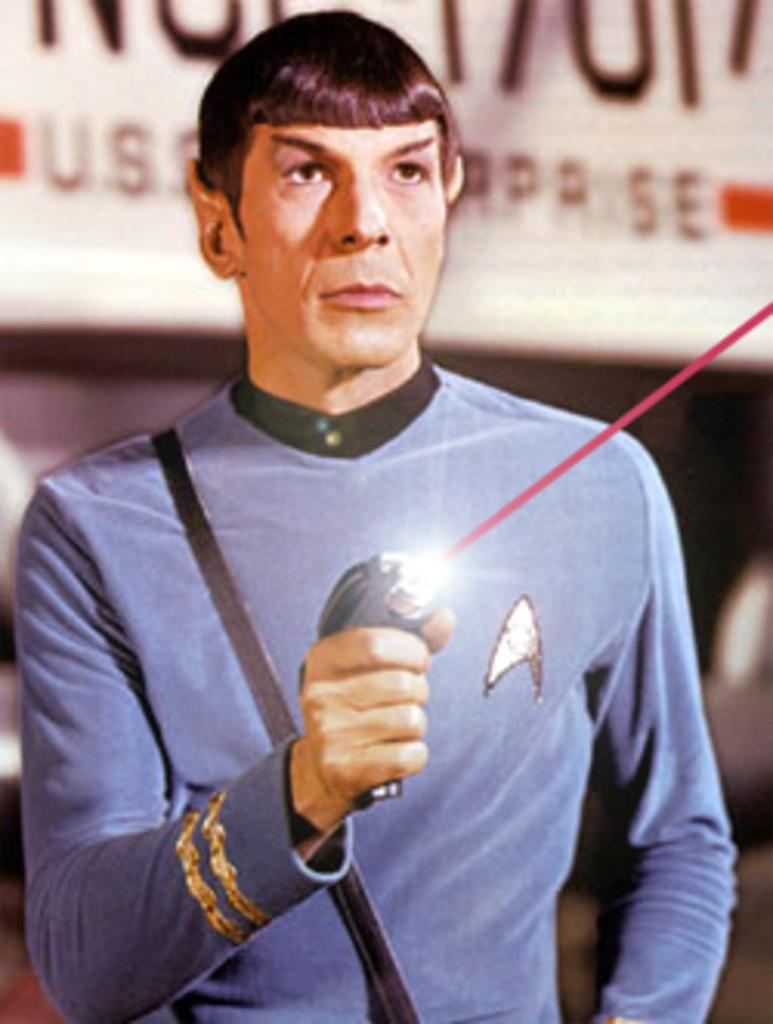Who is the main subject in the image? There is a person in the image. What is the person holding in the image? The person is holding a laser gun. Where is the person located in the image? The person is in the center of the image. How many sisters does the person in the image have? There is no information about the person's sisters in the image, so we cannot determine the number of sisters they have. 